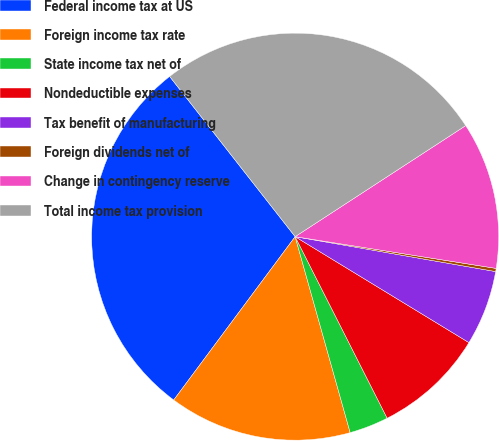Convert chart to OTSL. <chart><loc_0><loc_0><loc_500><loc_500><pie_chart><fcel>Federal income tax at US<fcel>Foreign income tax rate<fcel>State income tax net of<fcel>Nondeductible expenses<fcel>Tax benefit of manufacturing<fcel>Foreign dividends net of<fcel>Change in contingency reserve<fcel>Total income tax provision<nl><fcel>29.25%<fcel>14.53%<fcel>3.11%<fcel>8.82%<fcel>5.97%<fcel>0.25%<fcel>11.68%<fcel>26.39%<nl></chart> 